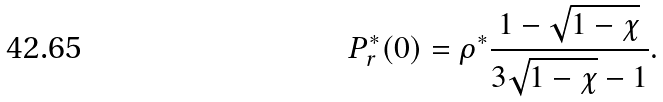Convert formula to latex. <formula><loc_0><loc_0><loc_500><loc_500>P ^ { * } _ { r } ( 0 ) = \rho ^ { * } \frac { 1 - \sqrt { 1 - \chi } } { 3 \sqrt { 1 - \chi } - 1 } .</formula> 